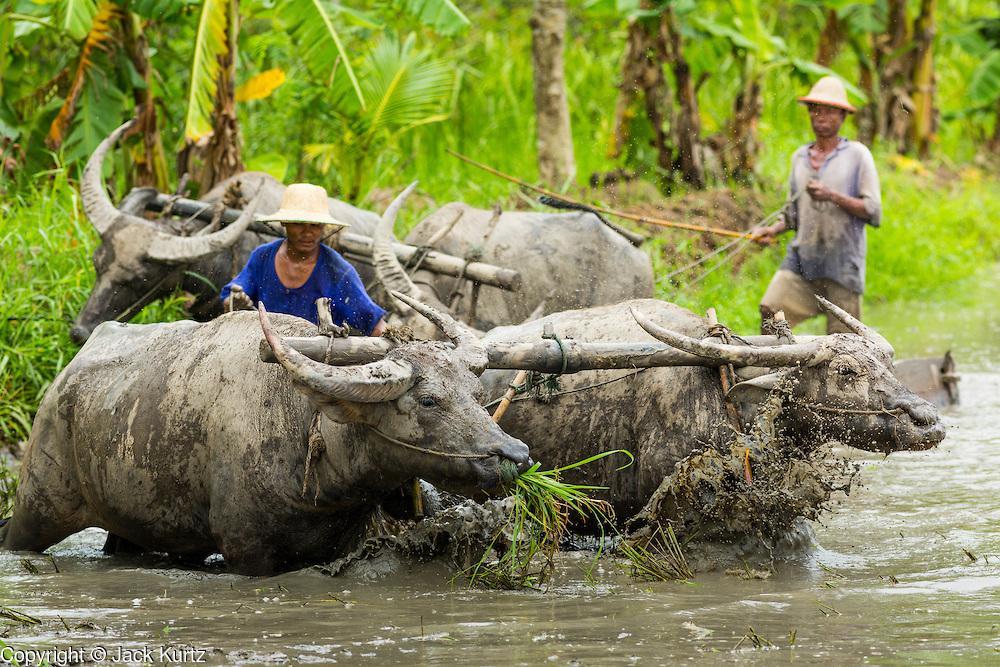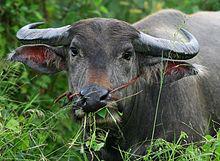The first image is the image on the left, the second image is the image on the right. Analyze the images presented: Is the assertion "Both images show men behind oxen pulling plows." valid? Answer yes or no. No. 